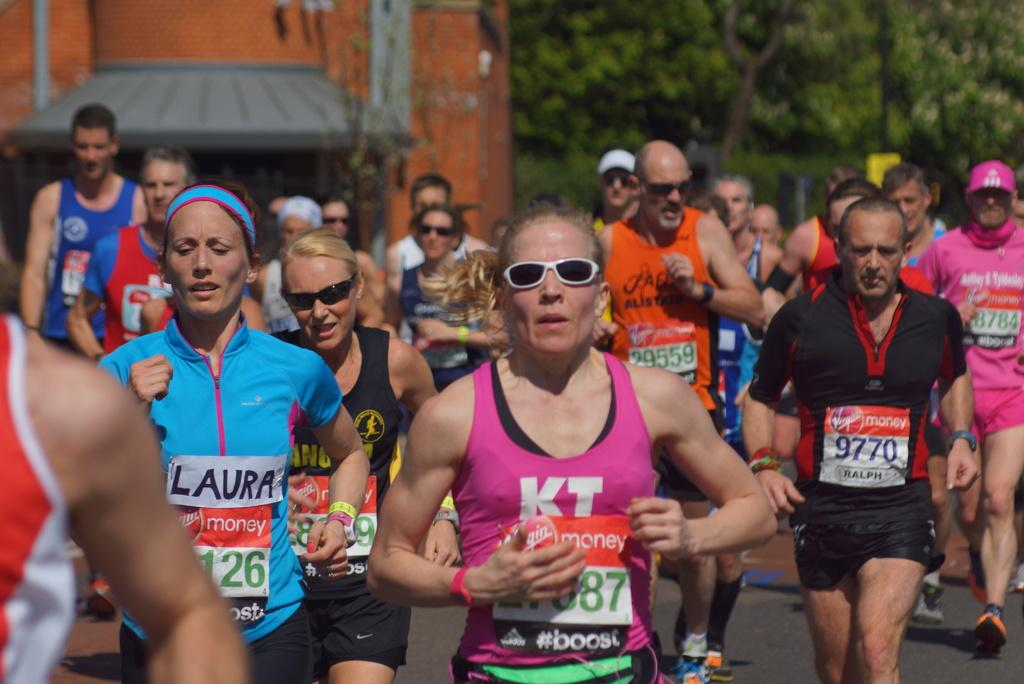What are the people in the image doing? There are people jogging in the image. What are the joggers wearing? The people are wearing colorful shirts. What can be seen in the background of the image? There is a building on the left side and a tree on the right side in the background of the image. Can you see a tray being carried by one of the joggers in the image? No, there is no tray visible in the image. Are any of the joggers wearing a mask in the image? No, the joggers are not wearing masks in the image. 